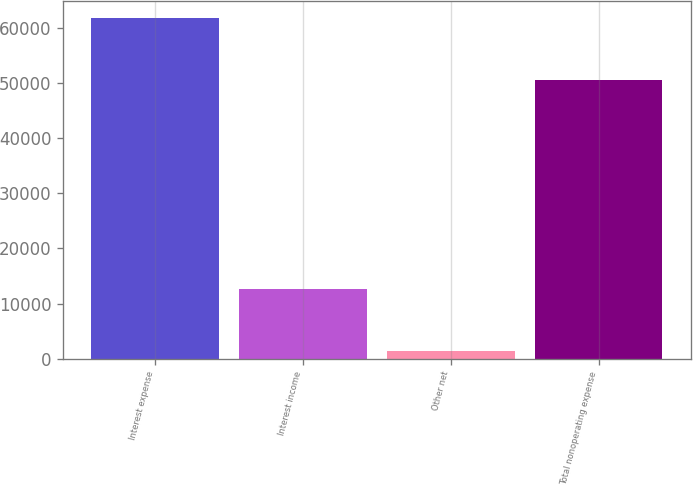Convert chart. <chart><loc_0><loc_0><loc_500><loc_500><bar_chart><fcel>Interest expense<fcel>Interest income<fcel>Other net<fcel>Total nonoperating expense<nl><fcel>61727<fcel>12596<fcel>1333<fcel>50464<nl></chart> 